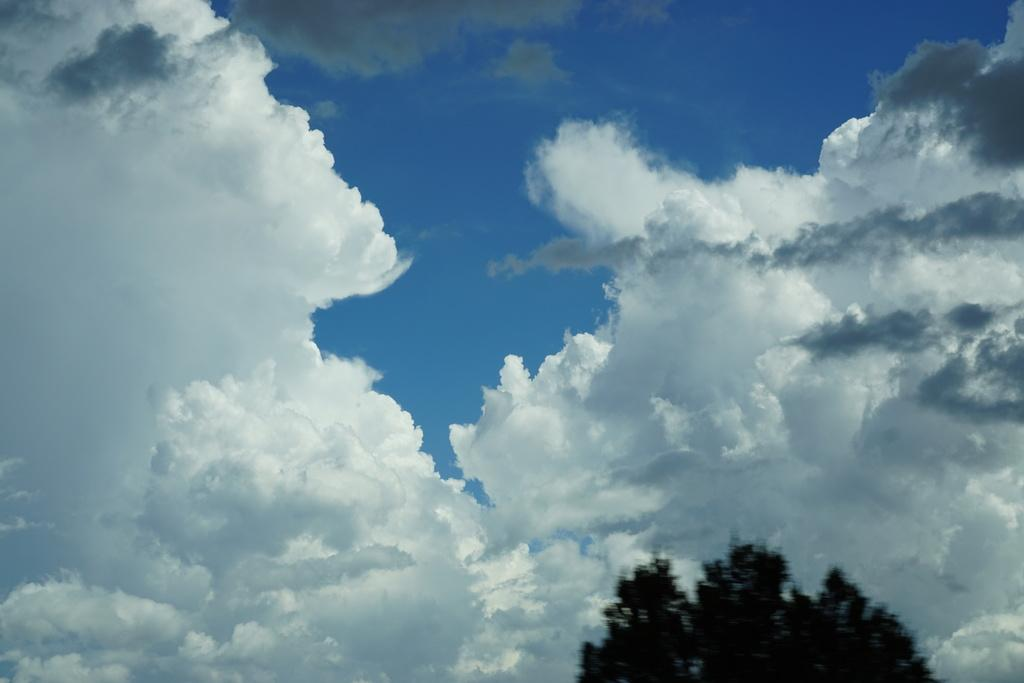What is one of the natural elements present in the image? There is a tree in the picture. How would you describe the sky in the image? The sky is blue and cloudy. What size is the drain visible in the image? There is no drain present in the image; it only features a tree and a blue, cloudy sky. 